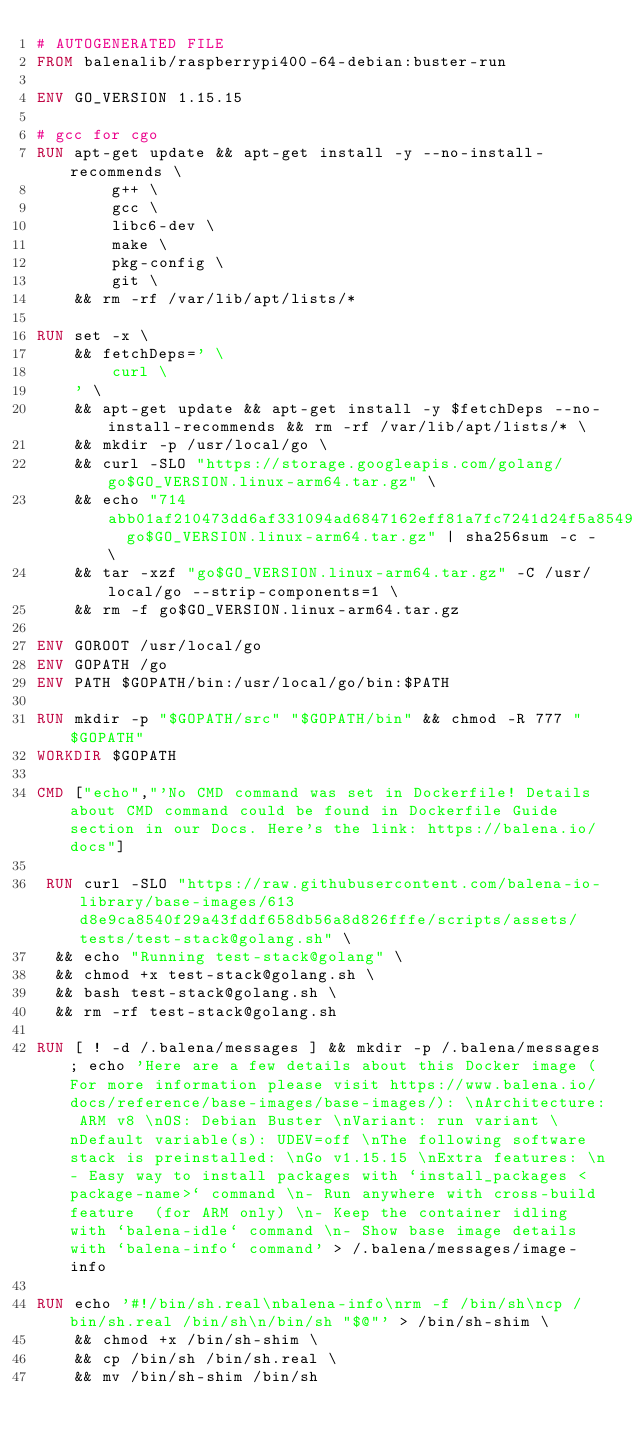<code> <loc_0><loc_0><loc_500><loc_500><_Dockerfile_># AUTOGENERATED FILE
FROM balenalib/raspberrypi400-64-debian:buster-run

ENV GO_VERSION 1.15.15

# gcc for cgo
RUN apt-get update && apt-get install -y --no-install-recommends \
		g++ \
		gcc \
		libc6-dev \
		make \
		pkg-config \
		git \
	&& rm -rf /var/lib/apt/lists/*

RUN set -x \
	&& fetchDeps=' \
		curl \
	' \
	&& apt-get update && apt-get install -y $fetchDeps --no-install-recommends && rm -rf /var/lib/apt/lists/* \
	&& mkdir -p /usr/local/go \
	&& curl -SLO "https://storage.googleapis.com/golang/go$GO_VERSION.linux-arm64.tar.gz" \
	&& echo "714abb01af210473dd6af331094ad6847162eff81a7fc7241d24f5a85496c9fa  go$GO_VERSION.linux-arm64.tar.gz" | sha256sum -c - \
	&& tar -xzf "go$GO_VERSION.linux-arm64.tar.gz" -C /usr/local/go --strip-components=1 \
	&& rm -f go$GO_VERSION.linux-arm64.tar.gz

ENV GOROOT /usr/local/go
ENV GOPATH /go
ENV PATH $GOPATH/bin:/usr/local/go/bin:$PATH

RUN mkdir -p "$GOPATH/src" "$GOPATH/bin" && chmod -R 777 "$GOPATH"
WORKDIR $GOPATH

CMD ["echo","'No CMD command was set in Dockerfile! Details about CMD command could be found in Dockerfile Guide section in our Docs. Here's the link: https://balena.io/docs"]

 RUN curl -SLO "https://raw.githubusercontent.com/balena-io-library/base-images/613d8e9ca8540f29a43fddf658db56a8d826fffe/scripts/assets/tests/test-stack@golang.sh" \
  && echo "Running test-stack@golang" \
  && chmod +x test-stack@golang.sh \
  && bash test-stack@golang.sh \
  && rm -rf test-stack@golang.sh 

RUN [ ! -d /.balena/messages ] && mkdir -p /.balena/messages; echo 'Here are a few details about this Docker image (For more information please visit https://www.balena.io/docs/reference/base-images/base-images/): \nArchitecture: ARM v8 \nOS: Debian Buster \nVariant: run variant \nDefault variable(s): UDEV=off \nThe following software stack is preinstalled: \nGo v1.15.15 \nExtra features: \n- Easy way to install packages with `install_packages <package-name>` command \n- Run anywhere with cross-build feature  (for ARM only) \n- Keep the container idling with `balena-idle` command \n- Show base image details with `balena-info` command' > /.balena/messages/image-info

RUN echo '#!/bin/sh.real\nbalena-info\nrm -f /bin/sh\ncp /bin/sh.real /bin/sh\n/bin/sh "$@"' > /bin/sh-shim \
	&& chmod +x /bin/sh-shim \
	&& cp /bin/sh /bin/sh.real \
	&& mv /bin/sh-shim /bin/sh</code> 